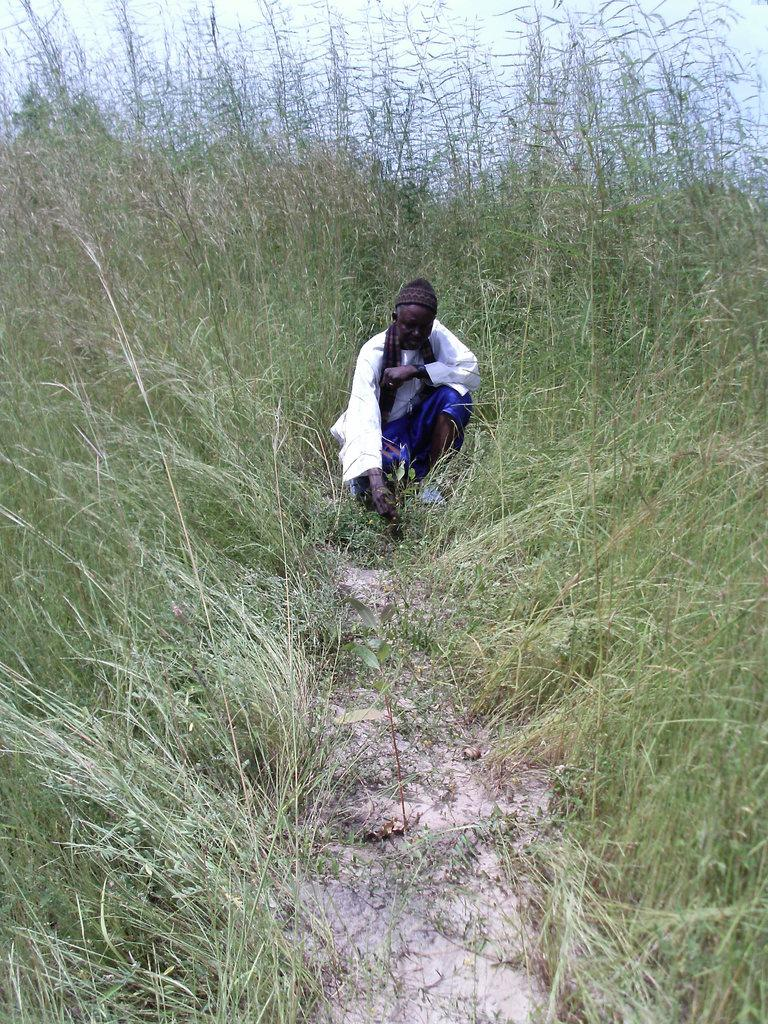What is the person in the image doing? The person is sitting on the ground in the image. What else can be seen in the image besides the person? There are plants visible in the image. What is visible in the background of the image? The sky is visible in the image. What type of business is being conducted in the image? There is no indication of any business activity in the image; it primarily features a person sitting on the ground and plants. How many toes can be seen on the person's feet in the image? The image does not show the person's feet, so it is impossible to determine the number of toes visible. 